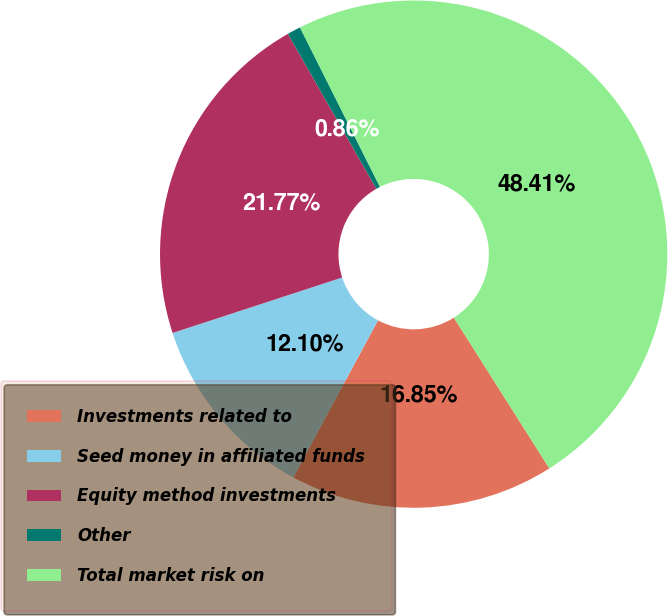Convert chart to OTSL. <chart><loc_0><loc_0><loc_500><loc_500><pie_chart><fcel>Investments related to<fcel>Seed money in affiliated funds<fcel>Equity method investments<fcel>Other<fcel>Total market risk on<nl><fcel>16.85%<fcel>12.1%<fcel>21.77%<fcel>0.86%<fcel>48.41%<nl></chart> 